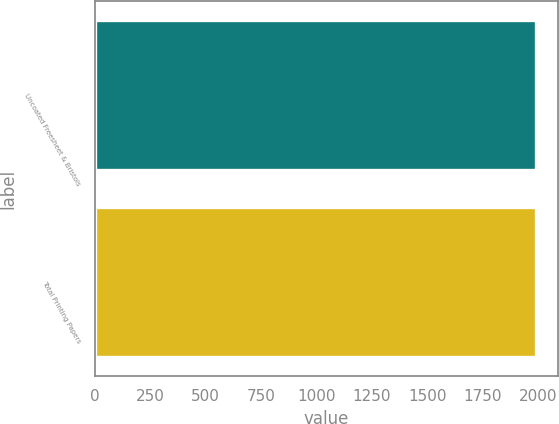Convert chart to OTSL. <chart><loc_0><loc_0><loc_500><loc_500><bar_chart><fcel>Uncoated Freesheet & Bristols<fcel>Total Printing Papers<nl><fcel>1990<fcel>1990.1<nl></chart> 